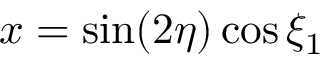Convert formula to latex. <formula><loc_0><loc_0><loc_500><loc_500>x = \sin ( 2 \eta ) \cos \xi _ { 1 }</formula> 